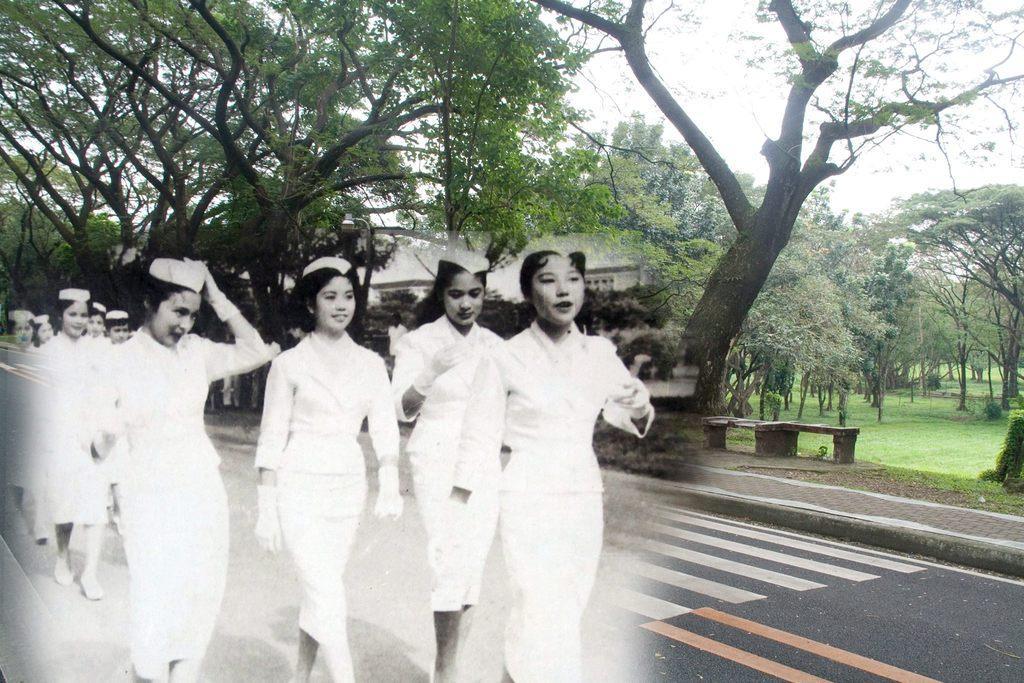How would you summarize this image in a sentence or two? In the picture I can see a group of women walking on the road. They are wearing a white color dress and a few of them are smiling. I can see the marble benches, a house and trees on the side of the road. 